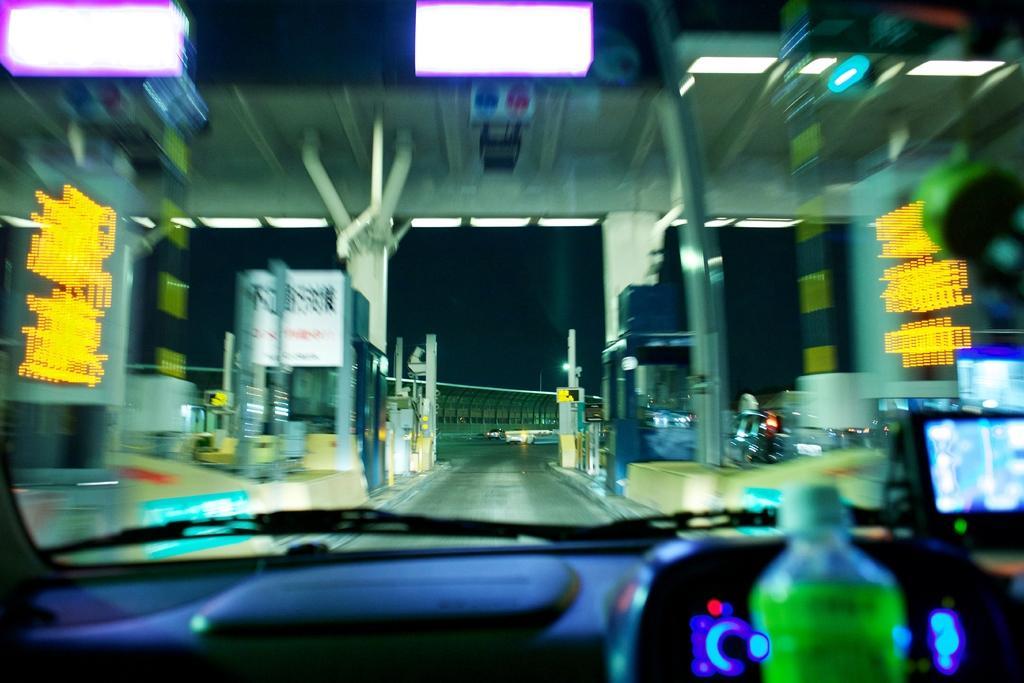Please provide a concise description of this image. In this picture there is a car, wiper and a windshield through which a fly over can be seen. There are two pillars and gate here. We can observe a road in the background. 